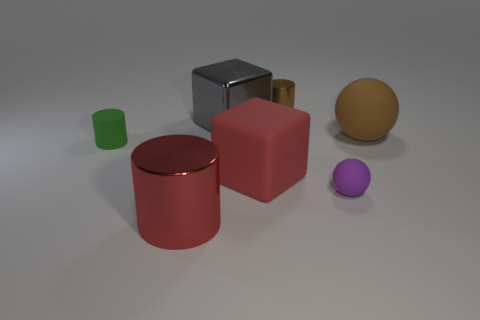Subtract all rubber cylinders. How many cylinders are left? 2 Add 3 large red metallic cylinders. How many objects exist? 10 Subtract all red cylinders. How many cylinders are left? 2 Subtract all blocks. How many objects are left? 5 Subtract all yellow cylinders. Subtract all brown balls. How many cylinders are left? 3 Add 1 small cylinders. How many small cylinders are left? 3 Add 1 large brown balls. How many large brown balls exist? 2 Subtract 1 red cylinders. How many objects are left? 6 Subtract all big gray metal cubes. Subtract all spheres. How many objects are left? 4 